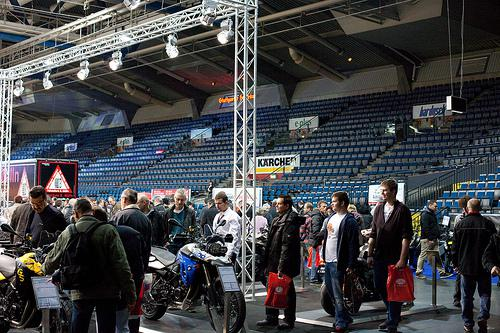Question: what are these people doing?
Choices:
A. Playing basketball.
B. On their phones.
C. Talking.
D. Standing in line.
Answer with the letter. Answer: D Question: where was this taken?
Choices:
A. Ball park.
B. At an arena.
C. From a swim meet.
D. At home.
Answer with the letter. Answer: B Question: what color are the bags the men are holding?
Choices:
A. Black.
B. Blue.
C. Red.
D. White.
Answer with the letter. Answer: C Question: who is at this exhibition?
Choices:
A. Nerds.
B. Old people.
C. Men.
D. Attractive women.
Answer with the letter. Answer: C Question: what shape is on the back of the truck?
Choices:
A. Diamond.
B. Square.
C. Triangle.
D. Circle.
Answer with the letter. Answer: C 